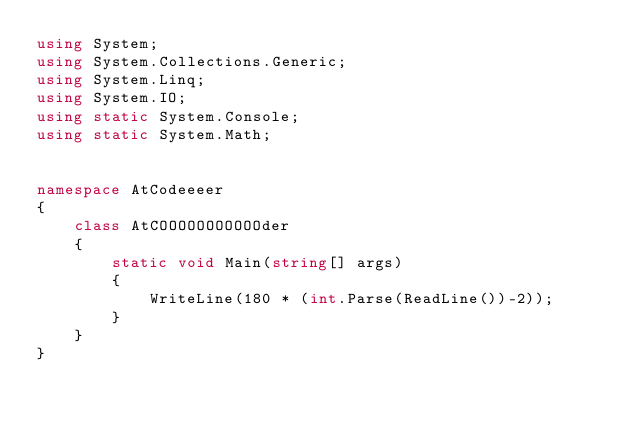<code> <loc_0><loc_0><loc_500><loc_500><_C#_>using System;
using System.Collections.Generic;
using System.Linq;
using System.IO;
using static System.Console;
using static System.Math;


namespace AtCodeeeer
{
    class AtCOOOOOOOOOOOder
    {
        static void Main(string[] args)
        {
            WriteLine(180 * (int.Parse(ReadLine())-2));
        }
    }
}
</code> 